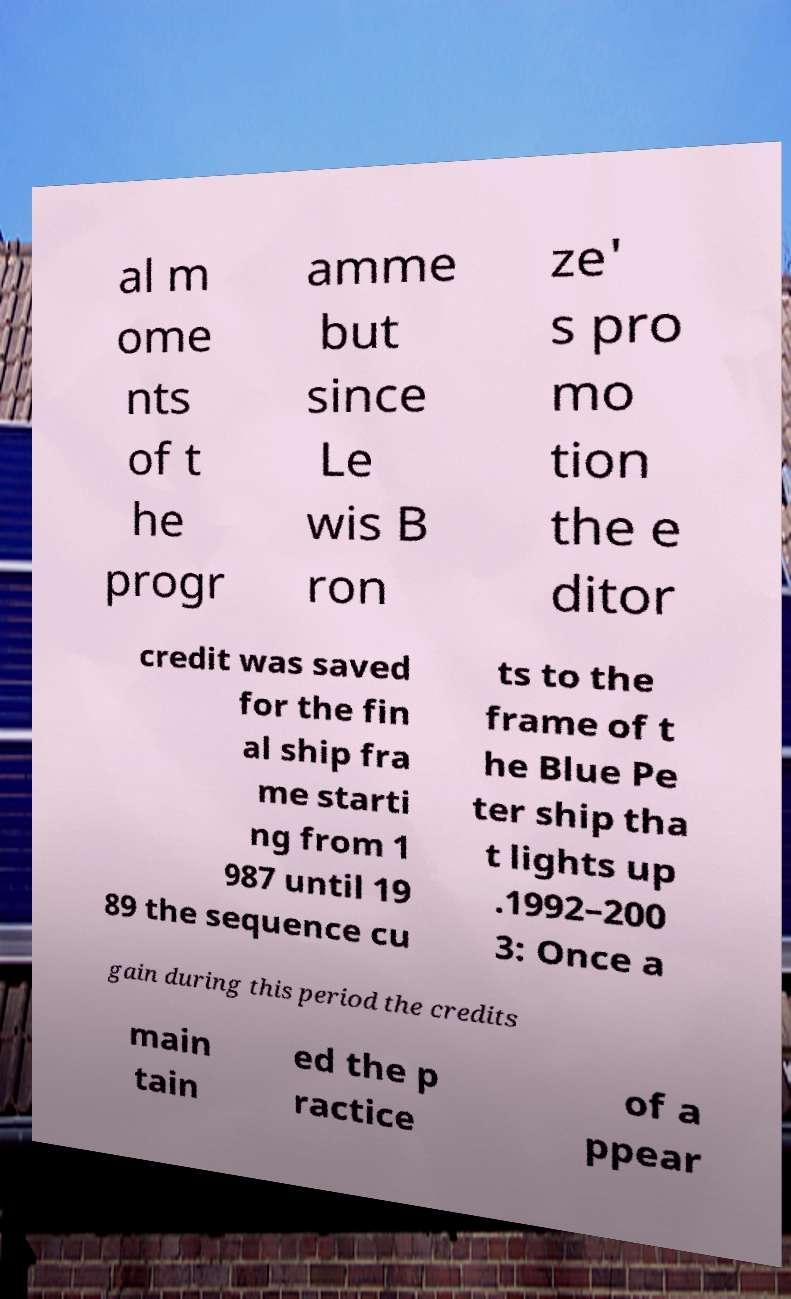Please identify and transcribe the text found in this image. al m ome nts of t he progr amme but since Le wis B ron ze' s pro mo tion the e ditor credit was saved for the fin al ship fra me starti ng from 1 987 until 19 89 the sequence cu ts to the frame of t he Blue Pe ter ship tha t lights up .1992–200 3: Once a gain during this period the credits main tain ed the p ractice of a ppear 